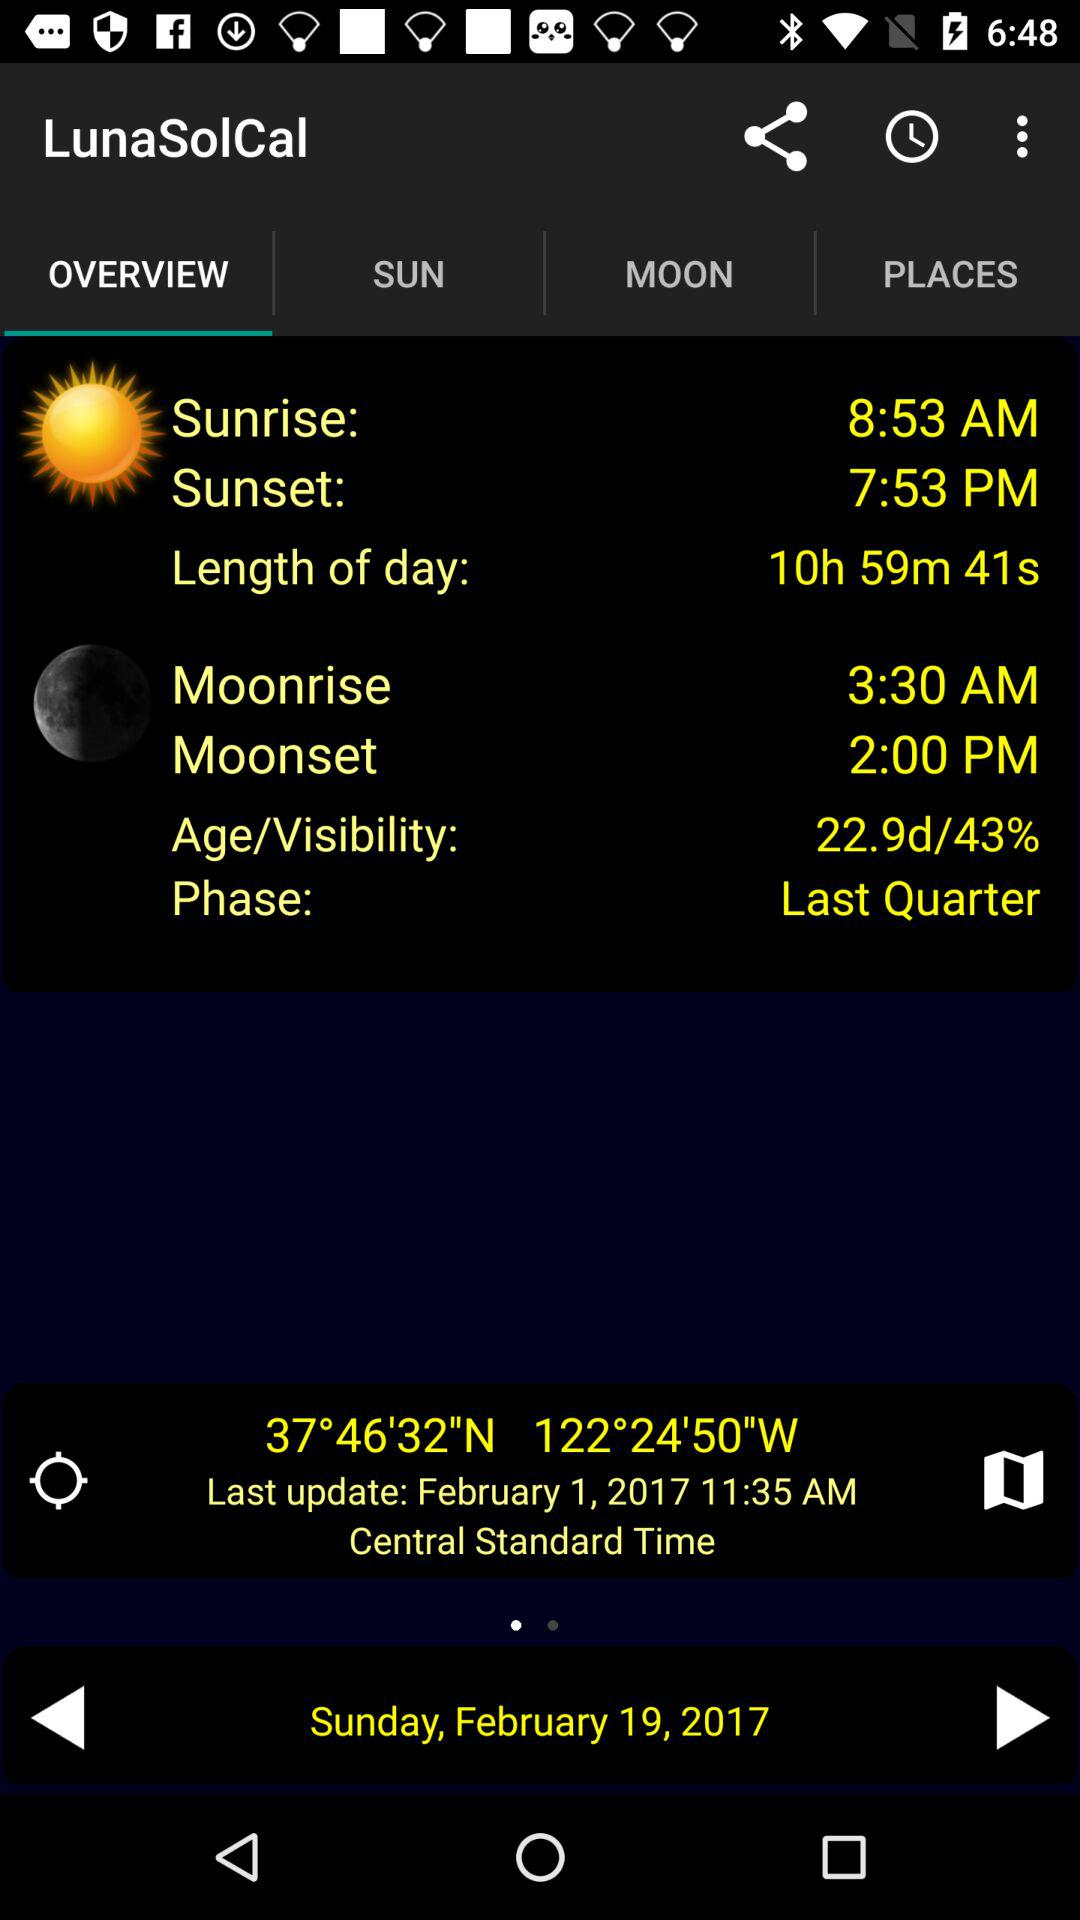What is the time of "Moonset"? The time is 2:00 PM. 